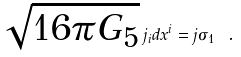<formula> <loc_0><loc_0><loc_500><loc_500>\sqrt { 1 6 \pi G _ { 5 } } \, j _ { i } d x ^ { i } = j \sigma _ { 1 } \ .</formula> 